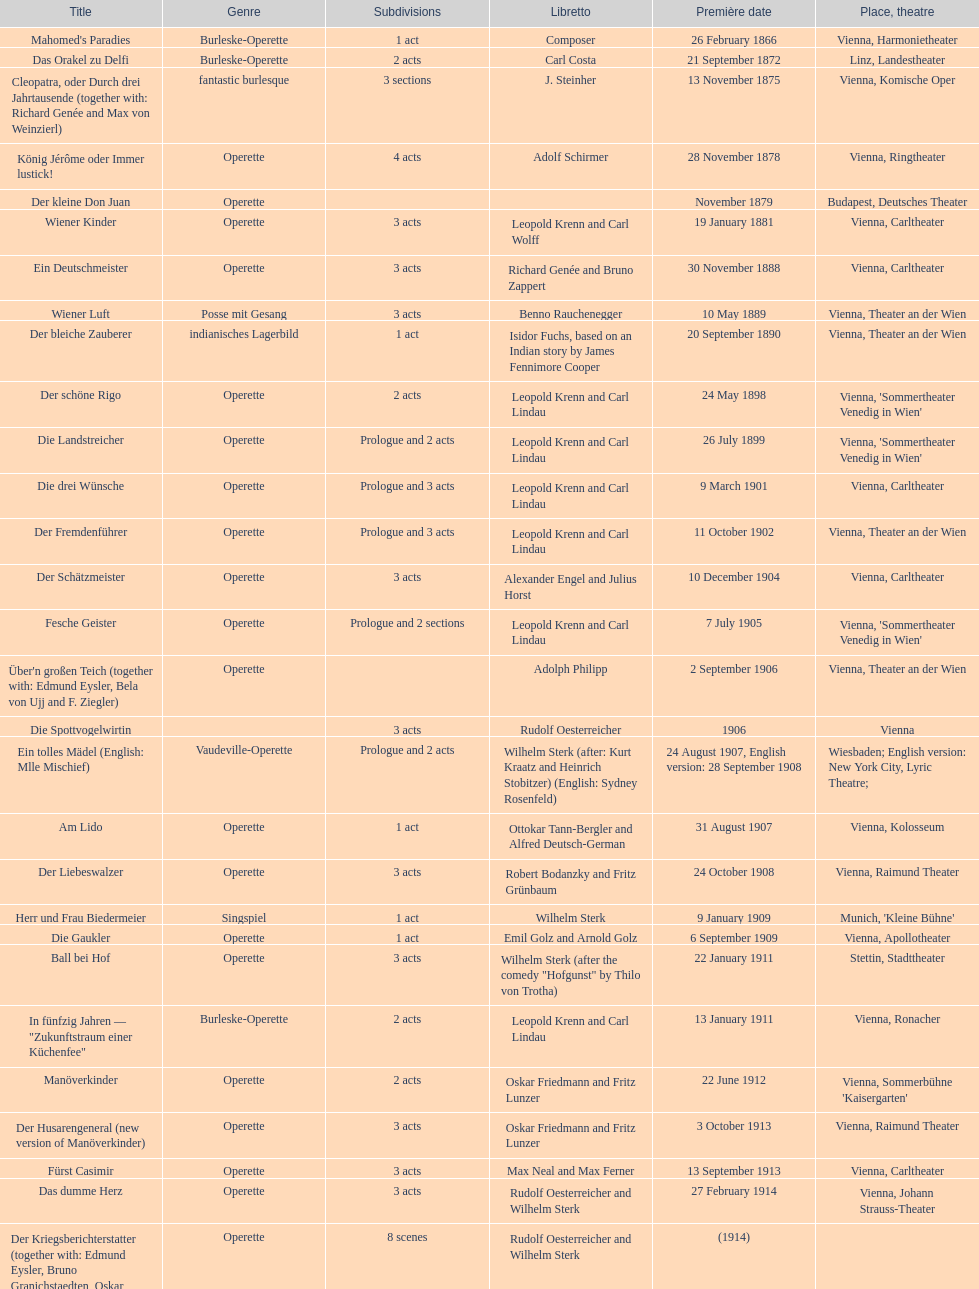Which year did he unveil his last operetta? 1930. 